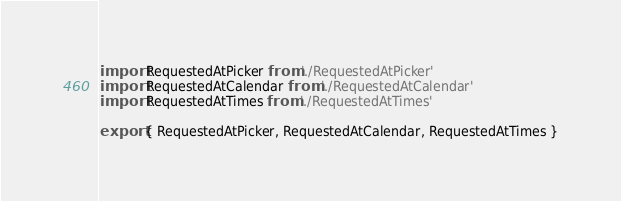<code> <loc_0><loc_0><loc_500><loc_500><_JavaScript_>import RequestedAtPicker from './RequestedAtPicker'
import RequestedAtCalendar from './RequestedAtCalendar'
import RequestedAtTimes from './RequestedAtTimes'

export { RequestedAtPicker, RequestedAtCalendar, RequestedAtTimes }
</code> 